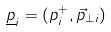Convert formula to latex. <formula><loc_0><loc_0><loc_500><loc_500>\underline { p } _ { i } = ( p _ { i } ^ { + } , \vec { p } _ { \perp i } )</formula> 